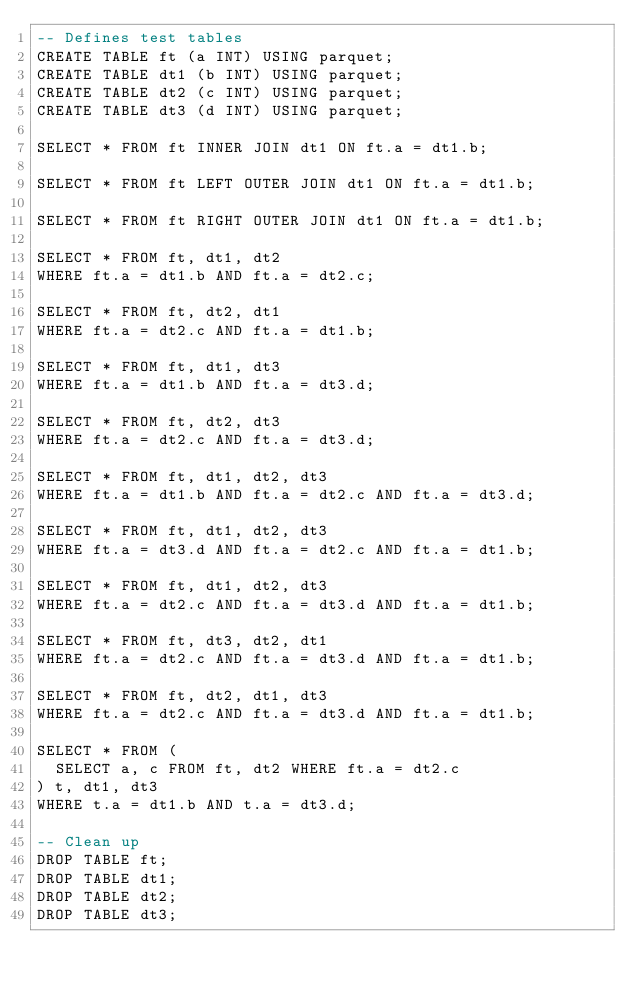<code> <loc_0><loc_0><loc_500><loc_500><_SQL_>-- Defines test tables
CREATE TABLE ft (a INT) USING parquet;
CREATE TABLE dt1 (b INT) USING parquet;
CREATE TABLE dt2 (c INT) USING parquet;
CREATE TABLE dt3 (d INT) USING parquet;

SELECT * FROM ft INNER JOIN dt1 ON ft.a = dt1.b;

SELECT * FROM ft LEFT OUTER JOIN dt1 ON ft.a = dt1.b;

SELECT * FROM ft RIGHT OUTER JOIN dt1 ON ft.a = dt1.b;

SELECT * FROM ft, dt1, dt2
WHERE ft.a = dt1.b AND ft.a = dt2.c;

SELECT * FROM ft, dt2, dt1
WHERE ft.a = dt2.c AND ft.a = dt1.b;

SELECT * FROM ft, dt1, dt3
WHERE ft.a = dt1.b AND ft.a = dt3.d;

SELECT * FROM ft, dt2, dt3
WHERE ft.a = dt2.c AND ft.a = dt3.d;

SELECT * FROM ft, dt1, dt2, dt3
WHERE ft.a = dt1.b AND ft.a = dt2.c AND ft.a = dt3.d;

SELECT * FROM ft, dt1, dt2, dt3
WHERE ft.a = dt3.d AND ft.a = dt2.c AND ft.a = dt1.b;

SELECT * FROM ft, dt1, dt2, dt3
WHERE ft.a = dt2.c AND ft.a = dt3.d AND ft.a = dt1.b;

SELECT * FROM ft, dt3, dt2, dt1
WHERE ft.a = dt2.c AND ft.a = dt3.d AND ft.a = dt1.b;

SELECT * FROM ft, dt2, dt1, dt3
WHERE ft.a = dt2.c AND ft.a = dt3.d AND ft.a = dt1.b;

SELECT * FROM (
  SELECT a, c FROM ft, dt2 WHERE ft.a = dt2.c
) t, dt1, dt3
WHERE t.a = dt1.b AND t.a = dt3.d;

-- Clean up
DROP TABLE ft;
DROP TABLE dt1;
DROP TABLE dt2;
DROP TABLE dt3;
</code> 